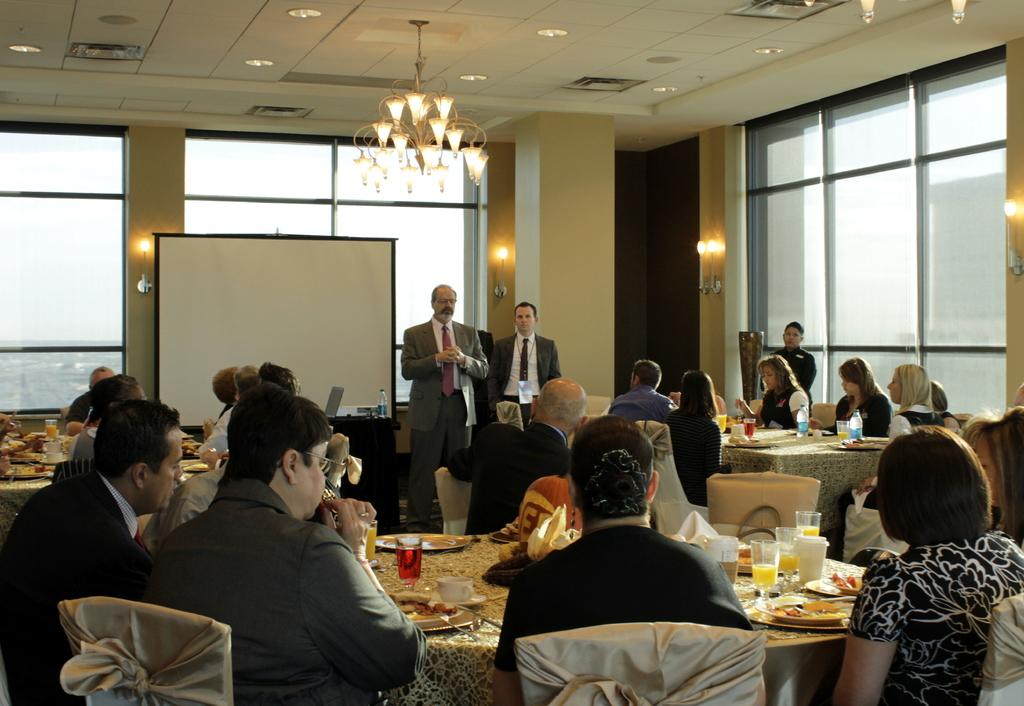How are the people in the image positioned? There are many people sitting in the image, and they are sitting on chairs. What is in front of the sitting people? There is a table in front of the sitting people. What can be found on the table? There are many food items on the table. Are there any other people in the image besides those sitting? Yes, there are two people standing near the sitting people. Can you see any masks on the people in the image? No, there are no masks present on the people in the image. 